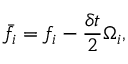<formula> <loc_0><loc_0><loc_500><loc_500>\bar { f } _ { i } = f _ { i } - \frac { \delta t } { 2 } \Omega _ { i } ,</formula> 